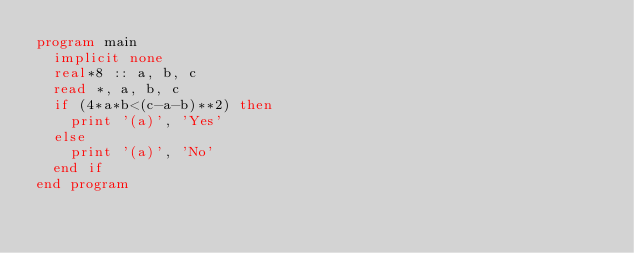<code> <loc_0><loc_0><loc_500><loc_500><_FORTRAN_>program main
  implicit none
  real*8 :: a, b, c
  read *, a, b, c
  if (4*a*b<(c-a-b)**2) then
    print '(a)', 'Yes'
  else
    print '(a)', 'No'
  end if
end program</code> 